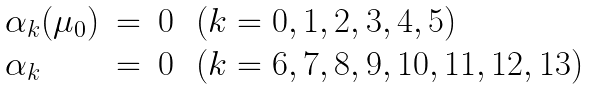<formula> <loc_0><loc_0><loc_500><loc_500>\begin{array} { l c c l } { \alpha } _ { k } ( { \mu } _ { 0 } ) & = & 0 & \, ( k = 0 , 1 , 2 , 3 , 4 , 5 ) \\ { \alpha } _ { k } & = & 0 & \, ( k = 6 , 7 , 8 , 9 , 1 0 , 1 1 , 1 2 , 1 3 ) \end{array}</formula> 